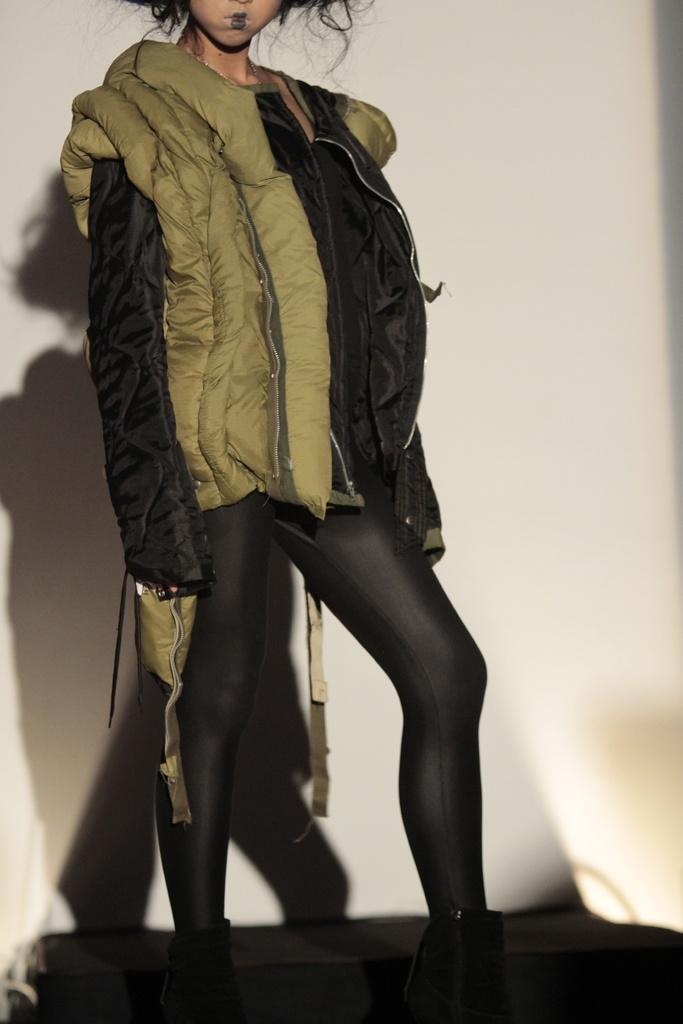Describe this image in one or two sentences. In this image I can see a person is wearing black and green color dress. Back I can see a white background. 